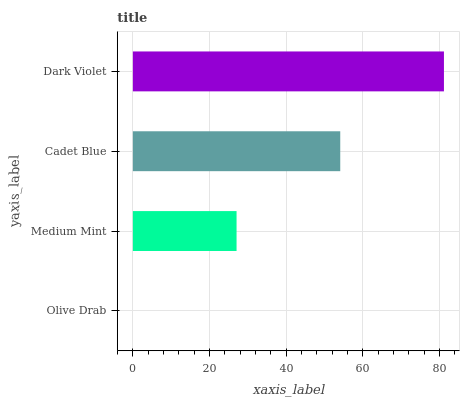Is Olive Drab the minimum?
Answer yes or no. Yes. Is Dark Violet the maximum?
Answer yes or no. Yes. Is Medium Mint the minimum?
Answer yes or no. No. Is Medium Mint the maximum?
Answer yes or no. No. Is Medium Mint greater than Olive Drab?
Answer yes or no. Yes. Is Olive Drab less than Medium Mint?
Answer yes or no. Yes. Is Olive Drab greater than Medium Mint?
Answer yes or no. No. Is Medium Mint less than Olive Drab?
Answer yes or no. No. Is Cadet Blue the high median?
Answer yes or no. Yes. Is Medium Mint the low median?
Answer yes or no. Yes. Is Olive Drab the high median?
Answer yes or no. No. Is Dark Violet the low median?
Answer yes or no. No. 